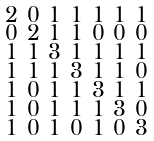Convert formula to latex. <formula><loc_0><loc_0><loc_500><loc_500>\begin{smallmatrix} 2 & 0 & 1 & 1 & 1 & 1 & 1 \\ 0 & 2 & 1 & 1 & 0 & 0 & 0 \\ 1 & 1 & 3 & 1 & 1 & 1 & 1 \\ 1 & 1 & 1 & 3 & 1 & 1 & 0 \\ 1 & 0 & 1 & 1 & 3 & 1 & 1 \\ 1 & 0 & 1 & 1 & 1 & 3 & 0 \\ 1 & 0 & 1 & 0 & 1 & 0 & 3 \end{smallmatrix}</formula> 